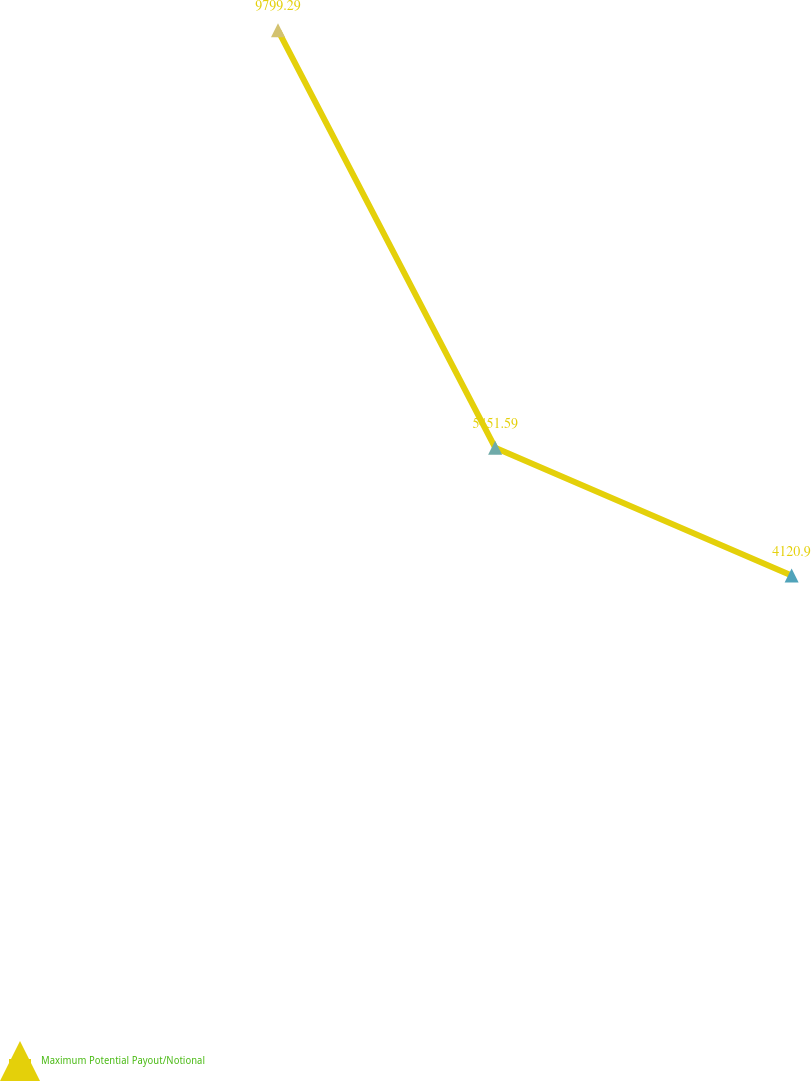Convert chart. <chart><loc_0><loc_0><loc_500><loc_500><line_chart><ecel><fcel>Maximum Potential Payout/Notional<nl><fcel>170881<fcel>9799.29<nl><fcel>403112<fcel>5451.59<nl><fcel>720160<fcel>4120.9<nl><fcel>1.53979e+06<fcel>17427.8<nl></chart> 